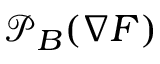<formula> <loc_0><loc_0><loc_500><loc_500>{ \mathcal { P } } _ { B } ( \nabla F )</formula> 